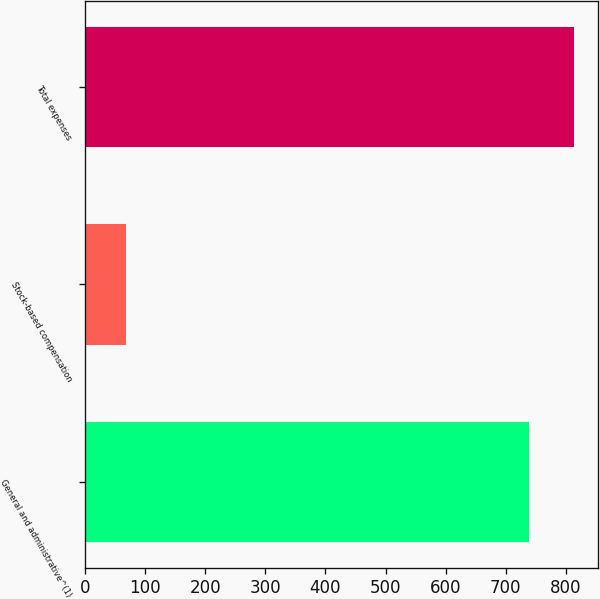Convert chart to OTSL. <chart><loc_0><loc_0><loc_500><loc_500><bar_chart><fcel>General and administrative^(1)<fcel>Stock-based compensation<fcel>Total expenses<nl><fcel>739<fcel>69<fcel>812.9<nl></chart> 